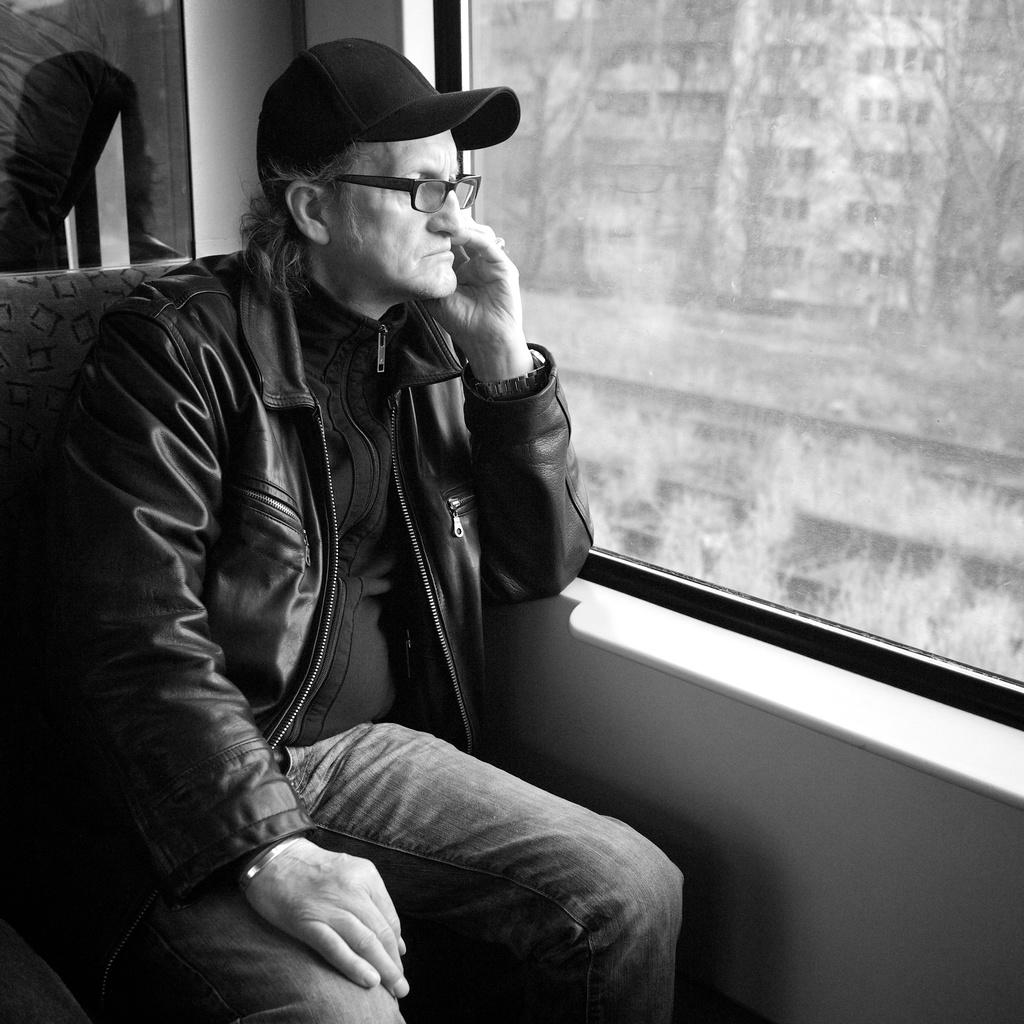What is the color scheme of the image? The image is black and white. What is the person in the image doing? The person is sitting in the image. What accessories is the person wearing? The person is wearing a cap, spectacles, a jacket, and jeans. What type of window can be seen in the image? There is a glass window in the image. What type of wool is being used to smash the glass window in the image? There is no wool or smashing of the glass window present in the image. 